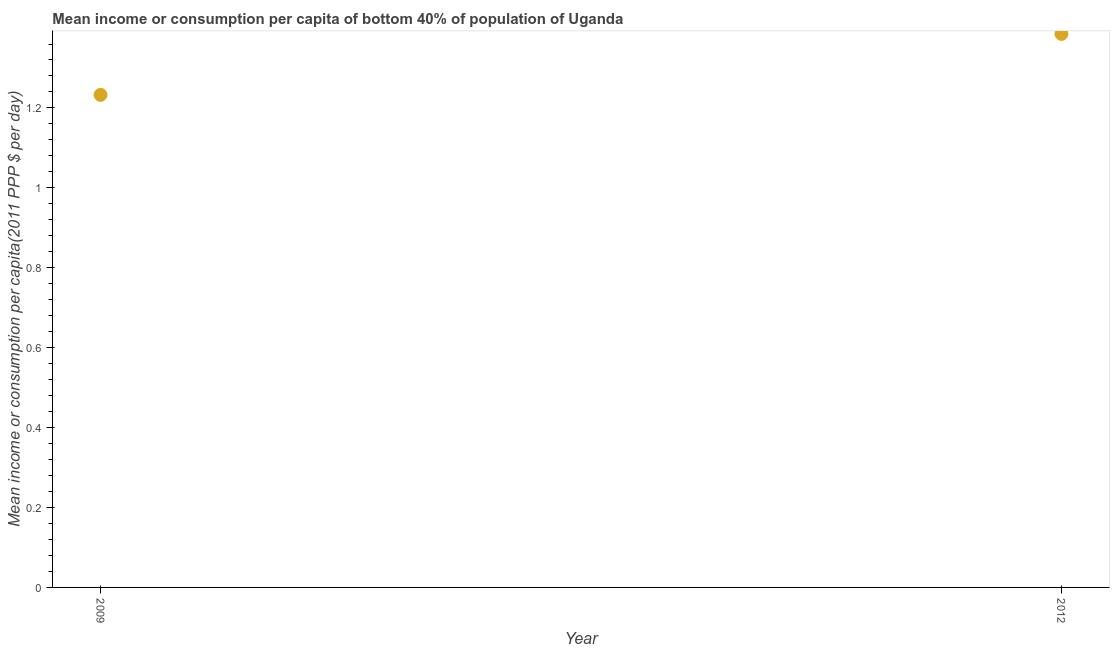What is the mean income or consumption in 2009?
Make the answer very short. 1.23. Across all years, what is the maximum mean income or consumption?
Offer a very short reply. 1.39. Across all years, what is the minimum mean income or consumption?
Ensure brevity in your answer.  1.23. In which year was the mean income or consumption maximum?
Provide a short and direct response. 2012. What is the sum of the mean income or consumption?
Ensure brevity in your answer.  2.62. What is the difference between the mean income or consumption in 2009 and 2012?
Offer a very short reply. -0.15. What is the average mean income or consumption per year?
Keep it short and to the point. 1.31. What is the median mean income or consumption?
Keep it short and to the point. 1.31. What is the ratio of the mean income or consumption in 2009 to that in 2012?
Offer a very short reply. 0.89. In how many years, is the mean income or consumption greater than the average mean income or consumption taken over all years?
Ensure brevity in your answer.  1. Does the mean income or consumption monotonically increase over the years?
Offer a terse response. Yes. How many dotlines are there?
Make the answer very short. 1. Are the values on the major ticks of Y-axis written in scientific E-notation?
Provide a short and direct response. No. What is the title of the graph?
Your answer should be very brief. Mean income or consumption per capita of bottom 40% of population of Uganda. What is the label or title of the Y-axis?
Give a very brief answer. Mean income or consumption per capita(2011 PPP $ per day). What is the Mean income or consumption per capita(2011 PPP $ per day) in 2009?
Offer a terse response. 1.23. What is the Mean income or consumption per capita(2011 PPP $ per day) in 2012?
Give a very brief answer. 1.39. What is the difference between the Mean income or consumption per capita(2011 PPP $ per day) in 2009 and 2012?
Offer a very short reply. -0.15. What is the ratio of the Mean income or consumption per capita(2011 PPP $ per day) in 2009 to that in 2012?
Offer a very short reply. 0.89. 